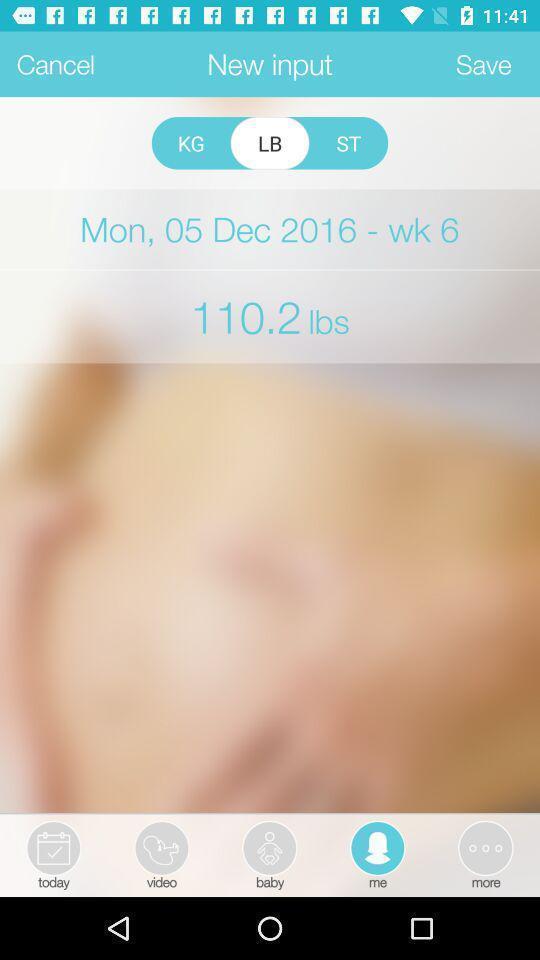Summarize the information in this screenshot. Screen shows a profiles input. 